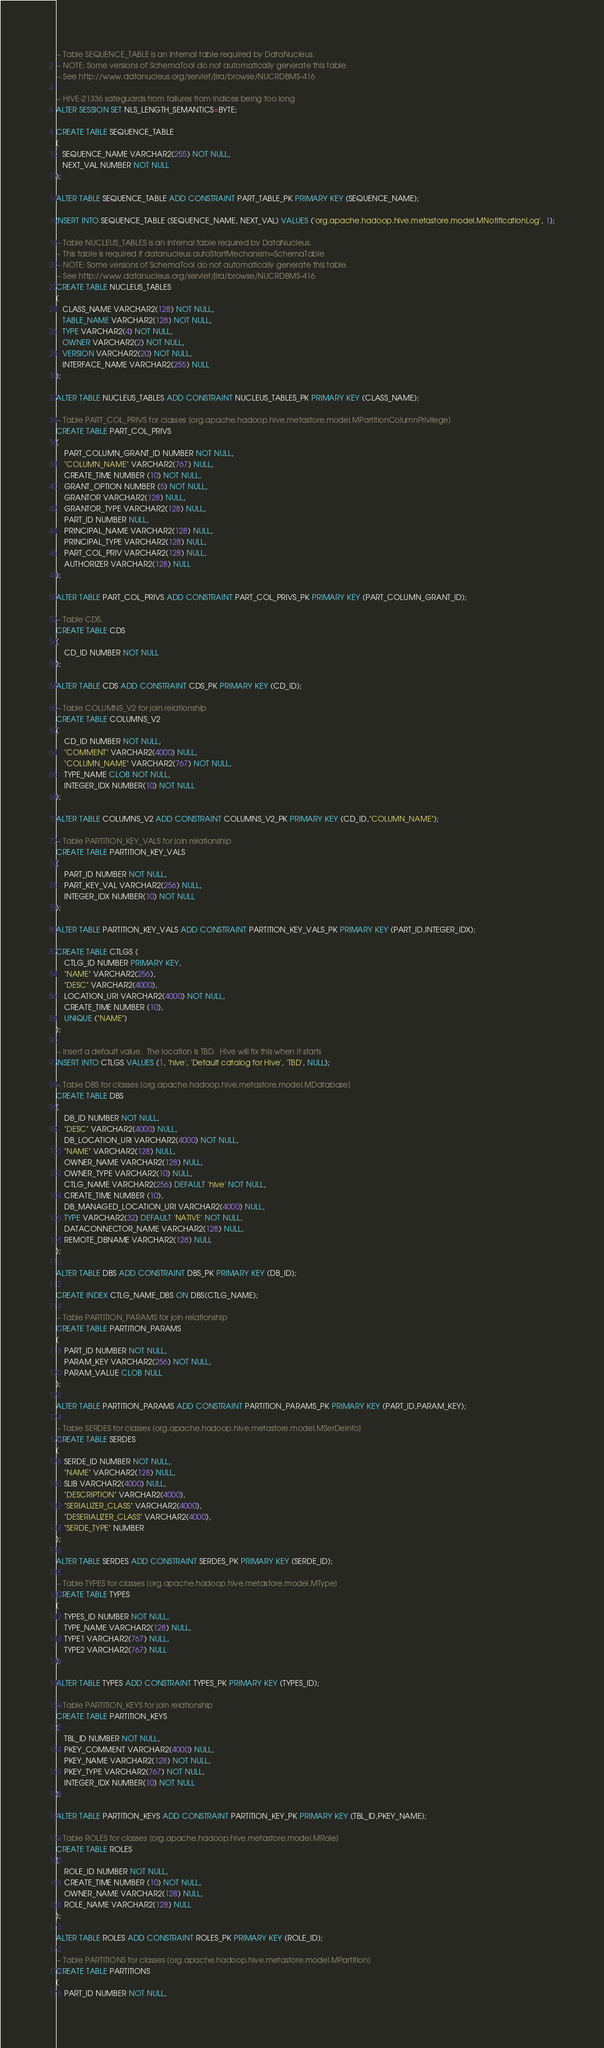Convert code to text. <code><loc_0><loc_0><loc_500><loc_500><_SQL_>-- Table SEQUENCE_TABLE is an internal table required by DataNucleus.
-- NOTE: Some versions of SchemaTool do not automatically generate this table.
-- See http://www.datanucleus.org/servlet/jira/browse/NUCRDBMS-416

-- HIVE-21336 safeguards from failures from indices being too long
ALTER SESSION SET NLS_LENGTH_SEMANTICS=BYTE;

CREATE TABLE SEQUENCE_TABLE
(
   SEQUENCE_NAME VARCHAR2(255) NOT NULL,
   NEXT_VAL NUMBER NOT NULL
);

ALTER TABLE SEQUENCE_TABLE ADD CONSTRAINT PART_TABLE_PK PRIMARY KEY (SEQUENCE_NAME);

INSERT INTO SEQUENCE_TABLE (SEQUENCE_NAME, NEXT_VAL) VALUES ('org.apache.hadoop.hive.metastore.model.MNotificationLog', 1);

-- Table NUCLEUS_TABLES is an internal table required by DataNucleus.
-- This table is required if datanucleus.autoStartMechanism=SchemaTable
-- NOTE: Some versions of SchemaTool do not automatically generate this table.
-- See http://www.datanucleus.org/servlet/jira/browse/NUCRDBMS-416
CREATE TABLE NUCLEUS_TABLES
(
   CLASS_NAME VARCHAR2(128) NOT NULL,
   TABLE_NAME VARCHAR2(128) NOT NULL,
   TYPE VARCHAR2(4) NOT NULL,
   OWNER VARCHAR2(2) NOT NULL,
   VERSION VARCHAR2(20) NOT NULL,
   INTERFACE_NAME VARCHAR2(255) NULL
);

ALTER TABLE NUCLEUS_TABLES ADD CONSTRAINT NUCLEUS_TABLES_PK PRIMARY KEY (CLASS_NAME);

-- Table PART_COL_PRIVS for classes [org.apache.hadoop.hive.metastore.model.MPartitionColumnPrivilege]
CREATE TABLE PART_COL_PRIVS
(
    PART_COLUMN_GRANT_ID NUMBER NOT NULL,
    "COLUMN_NAME" VARCHAR2(767) NULL,
    CREATE_TIME NUMBER (10) NOT NULL,
    GRANT_OPTION NUMBER (5) NOT NULL,
    GRANTOR VARCHAR2(128) NULL,
    GRANTOR_TYPE VARCHAR2(128) NULL,
    PART_ID NUMBER NULL,
    PRINCIPAL_NAME VARCHAR2(128) NULL,
    PRINCIPAL_TYPE VARCHAR2(128) NULL,
    PART_COL_PRIV VARCHAR2(128) NULL,
    AUTHORIZER VARCHAR2(128) NULL
);

ALTER TABLE PART_COL_PRIVS ADD CONSTRAINT PART_COL_PRIVS_PK PRIMARY KEY (PART_COLUMN_GRANT_ID);

-- Table CDS.
CREATE TABLE CDS
(
    CD_ID NUMBER NOT NULL
);

ALTER TABLE CDS ADD CONSTRAINT CDS_PK PRIMARY KEY (CD_ID);

-- Table COLUMNS_V2 for join relationship
CREATE TABLE COLUMNS_V2
(
    CD_ID NUMBER NOT NULL,
    "COMMENT" VARCHAR2(4000) NULL,
    "COLUMN_NAME" VARCHAR2(767) NOT NULL,
    TYPE_NAME CLOB NOT NULL,
    INTEGER_IDX NUMBER(10) NOT NULL
);

ALTER TABLE COLUMNS_V2 ADD CONSTRAINT COLUMNS_V2_PK PRIMARY KEY (CD_ID,"COLUMN_NAME");

-- Table PARTITION_KEY_VALS for join relationship
CREATE TABLE PARTITION_KEY_VALS
(
    PART_ID NUMBER NOT NULL,
    PART_KEY_VAL VARCHAR2(256) NULL,
    INTEGER_IDX NUMBER(10) NOT NULL
);

ALTER TABLE PARTITION_KEY_VALS ADD CONSTRAINT PARTITION_KEY_VALS_PK PRIMARY KEY (PART_ID,INTEGER_IDX);

CREATE TABLE CTLGS (
    CTLG_ID NUMBER PRIMARY KEY,
    "NAME" VARCHAR2(256),
    "DESC" VARCHAR2(4000),
    LOCATION_URI VARCHAR2(4000) NOT NULL,
    CREATE_TIME NUMBER (10),
    UNIQUE ("NAME")
);

-- Insert a default value.  The location is TBD.  Hive will fix this when it starts
INSERT INTO CTLGS VALUES (1, 'hive', 'Default catalog for Hive', 'TBD', NULL);

-- Table DBS for classes [org.apache.hadoop.hive.metastore.model.MDatabase]
CREATE TABLE DBS
(
    DB_ID NUMBER NOT NULL,
    "DESC" VARCHAR2(4000) NULL,
    DB_LOCATION_URI VARCHAR2(4000) NOT NULL,
    "NAME" VARCHAR2(128) NULL,
    OWNER_NAME VARCHAR2(128) NULL,
    OWNER_TYPE VARCHAR2(10) NULL,
    CTLG_NAME VARCHAR2(256) DEFAULT 'hive' NOT NULL,
    CREATE_TIME NUMBER (10),
    DB_MANAGED_LOCATION_URI VARCHAR2(4000) NULL,
    TYPE VARCHAR2(32) DEFAULT 'NATIVE' NOT NULL,
    DATACONNECTOR_NAME VARCHAR2(128) NULL,
    REMOTE_DBNAME VARCHAR2(128) NULL
);

ALTER TABLE DBS ADD CONSTRAINT DBS_PK PRIMARY KEY (DB_ID);

CREATE INDEX CTLG_NAME_DBS ON DBS(CTLG_NAME);

-- Table PARTITION_PARAMS for join relationship
CREATE TABLE PARTITION_PARAMS
(
    PART_ID NUMBER NOT NULL,
    PARAM_KEY VARCHAR2(256) NOT NULL,
    PARAM_VALUE CLOB NULL
);

ALTER TABLE PARTITION_PARAMS ADD CONSTRAINT PARTITION_PARAMS_PK PRIMARY KEY (PART_ID,PARAM_KEY);

-- Table SERDES for classes [org.apache.hadoop.hive.metastore.model.MSerDeInfo]
CREATE TABLE SERDES
(
    SERDE_ID NUMBER NOT NULL,
    "NAME" VARCHAR2(128) NULL,
    SLIB VARCHAR2(4000) NULL,
    "DESCRIPTION" VARCHAR2(4000),
    "SERIALIZER_CLASS" VARCHAR2(4000),
    "DESERIALIZER_CLASS" VARCHAR2(4000),
    "SERDE_TYPE" NUMBER
);

ALTER TABLE SERDES ADD CONSTRAINT SERDES_PK PRIMARY KEY (SERDE_ID);

-- Table TYPES for classes [org.apache.hadoop.hive.metastore.model.MType]
CREATE TABLE TYPES
(
    TYPES_ID NUMBER NOT NULL,
    TYPE_NAME VARCHAR2(128) NULL,
    TYPE1 VARCHAR2(767) NULL,
    TYPE2 VARCHAR2(767) NULL
);

ALTER TABLE TYPES ADD CONSTRAINT TYPES_PK PRIMARY KEY (TYPES_ID);

-- Table PARTITION_KEYS for join relationship
CREATE TABLE PARTITION_KEYS
(
    TBL_ID NUMBER NOT NULL,
    PKEY_COMMENT VARCHAR2(4000) NULL,
    PKEY_NAME VARCHAR2(128) NOT NULL,
    PKEY_TYPE VARCHAR2(767) NOT NULL,
    INTEGER_IDX NUMBER(10) NOT NULL
);

ALTER TABLE PARTITION_KEYS ADD CONSTRAINT PARTITION_KEY_PK PRIMARY KEY (TBL_ID,PKEY_NAME);

-- Table ROLES for classes [org.apache.hadoop.hive.metastore.model.MRole]
CREATE TABLE ROLES
(
    ROLE_ID NUMBER NOT NULL,
    CREATE_TIME NUMBER (10) NOT NULL,
    OWNER_NAME VARCHAR2(128) NULL,
    ROLE_NAME VARCHAR2(128) NULL
);

ALTER TABLE ROLES ADD CONSTRAINT ROLES_PK PRIMARY KEY (ROLE_ID);

-- Table PARTITIONS for classes [org.apache.hadoop.hive.metastore.model.MPartition]
CREATE TABLE PARTITIONS
(
    PART_ID NUMBER NOT NULL,</code> 